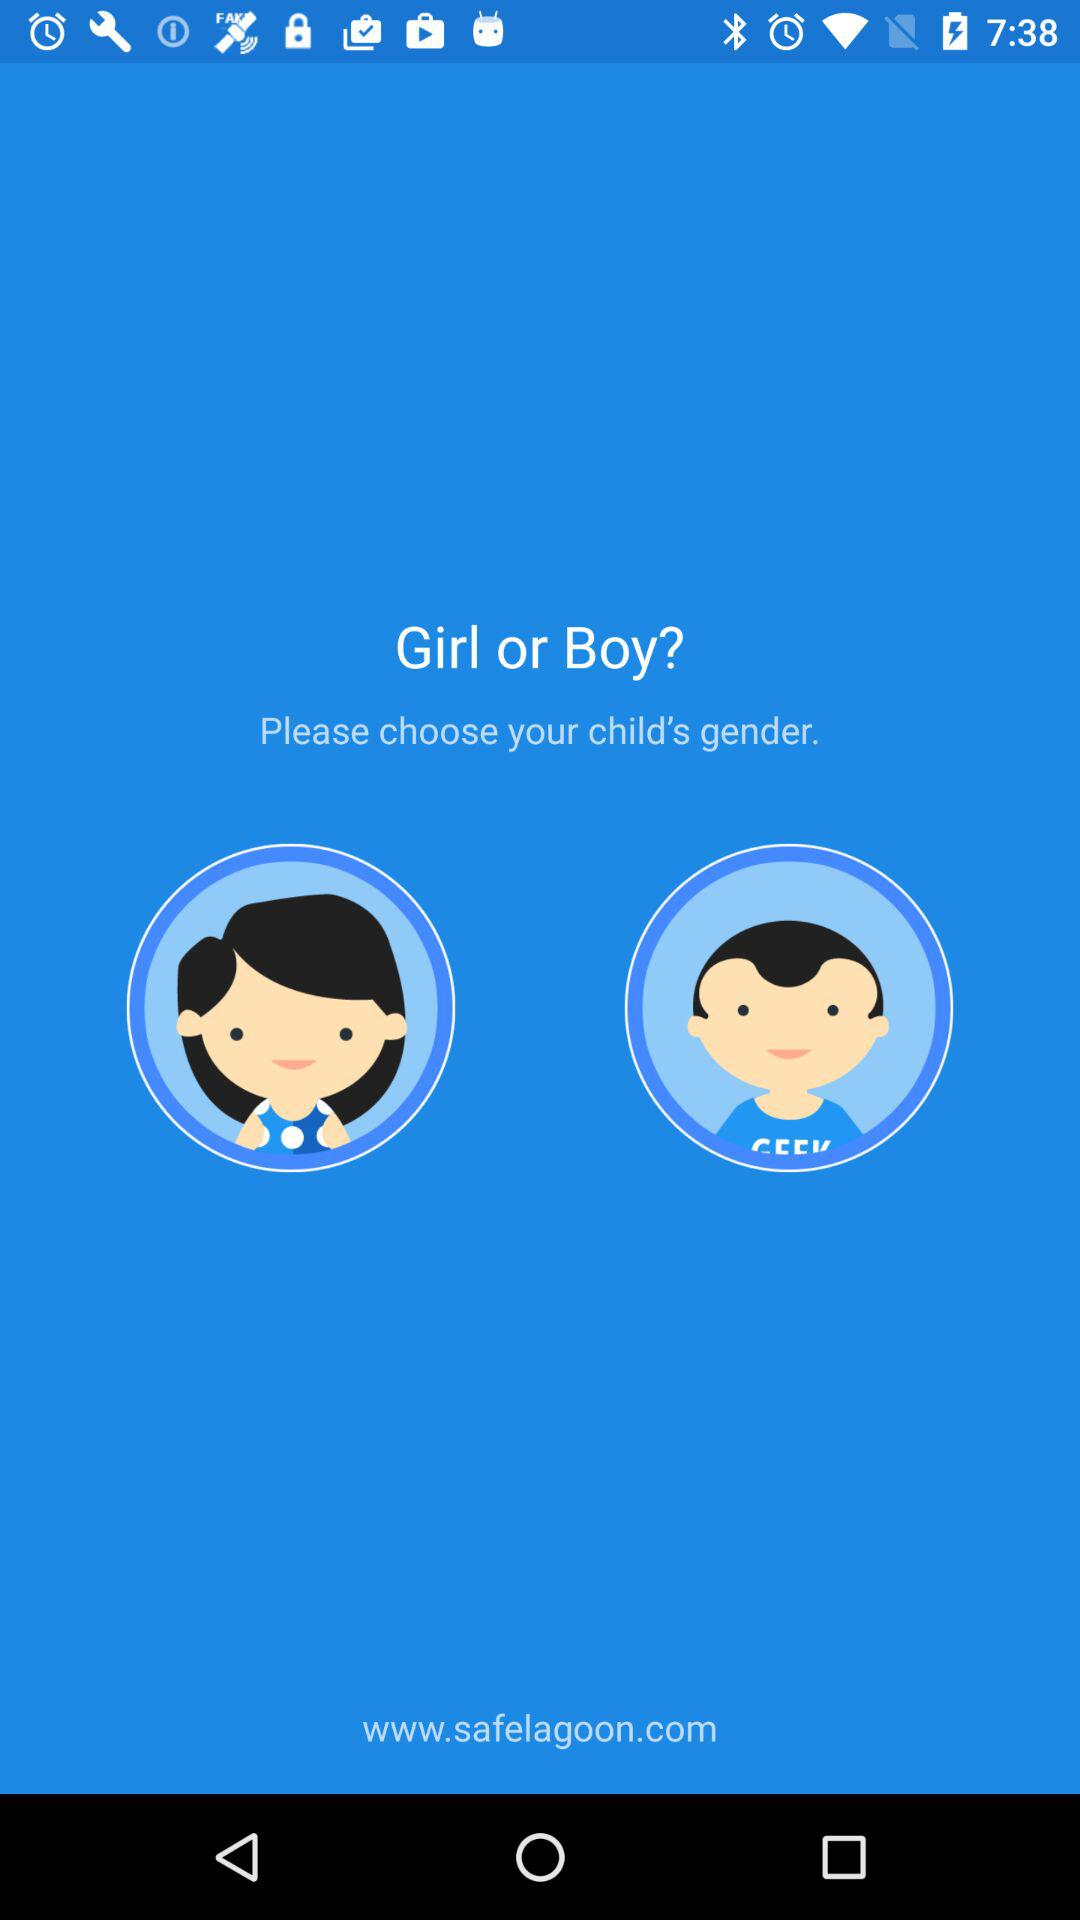How many gender options are there?
Answer the question using a single word or phrase. 2 